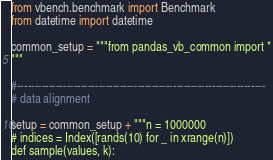Convert code to text. <code><loc_0><loc_0><loc_500><loc_500><_Python_>from vbench.benchmark import Benchmark
from datetime import datetime

common_setup = """from pandas_vb_common import *
"""

#----------------------------------------------------------------------
# data alignment

setup = common_setup + """n = 1000000
# indices = Index([rands(10) for _ in xrange(n)])
def sample(values, k):</code> 